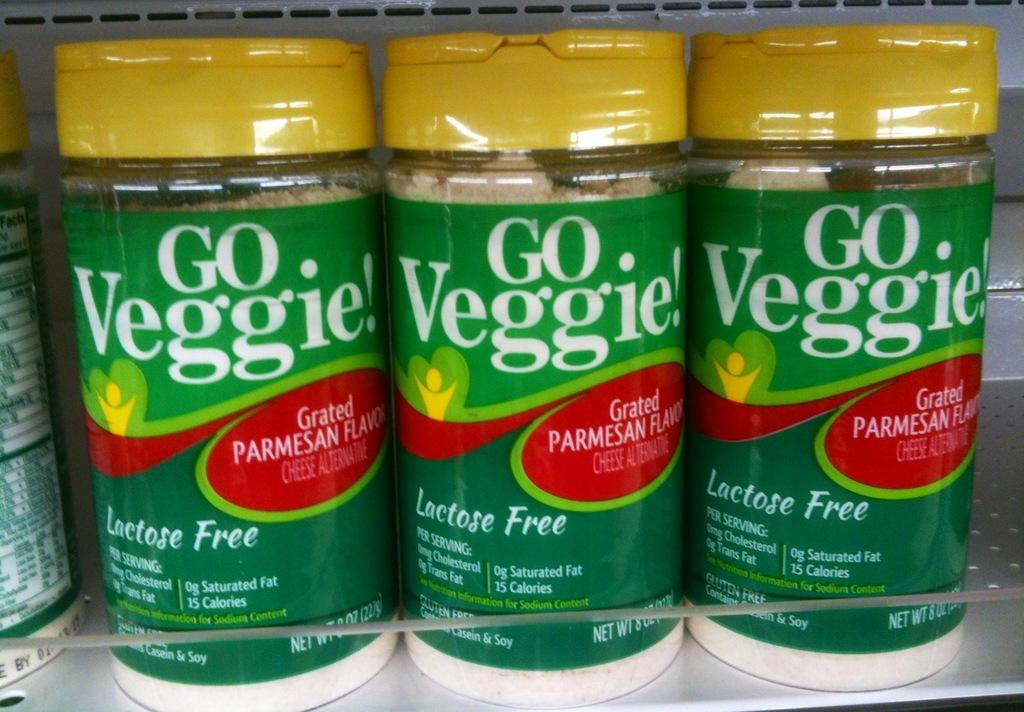<image>
Share a concise interpretation of the image provided. Some containers of Go Veggie! parmesan cheese alternative sit on a shelf. 